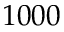<formula> <loc_0><loc_0><loc_500><loc_500>1 0 0 0</formula> 